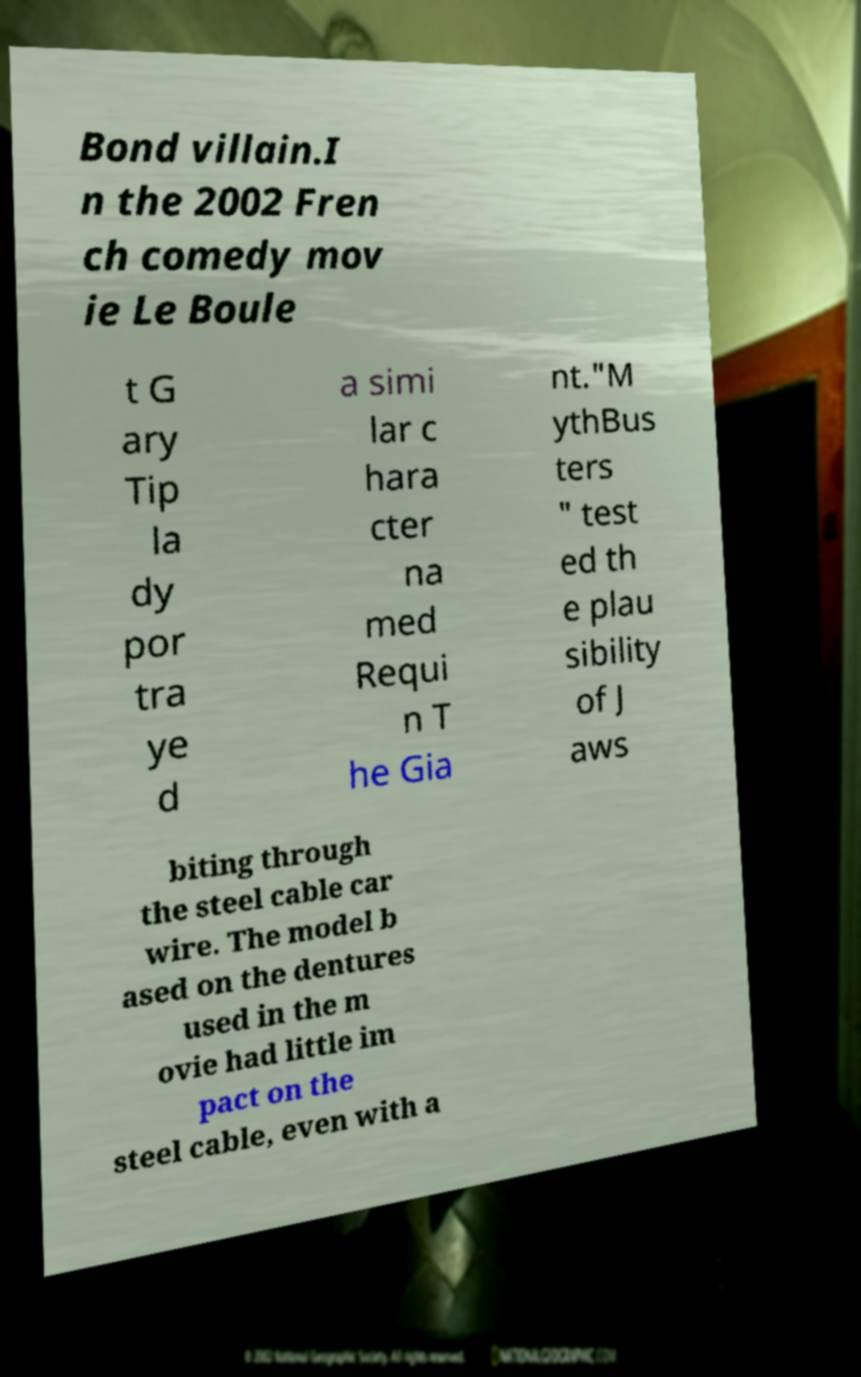Can you read and provide the text displayed in the image?This photo seems to have some interesting text. Can you extract and type it out for me? Bond villain.I n the 2002 Fren ch comedy mov ie Le Boule t G ary Tip la dy por tra ye d a simi lar c hara cter na med Requi n T he Gia nt."M ythBus ters " test ed th e plau sibility of J aws biting through the steel cable car wire. The model b ased on the dentures used in the m ovie had little im pact on the steel cable, even with a 